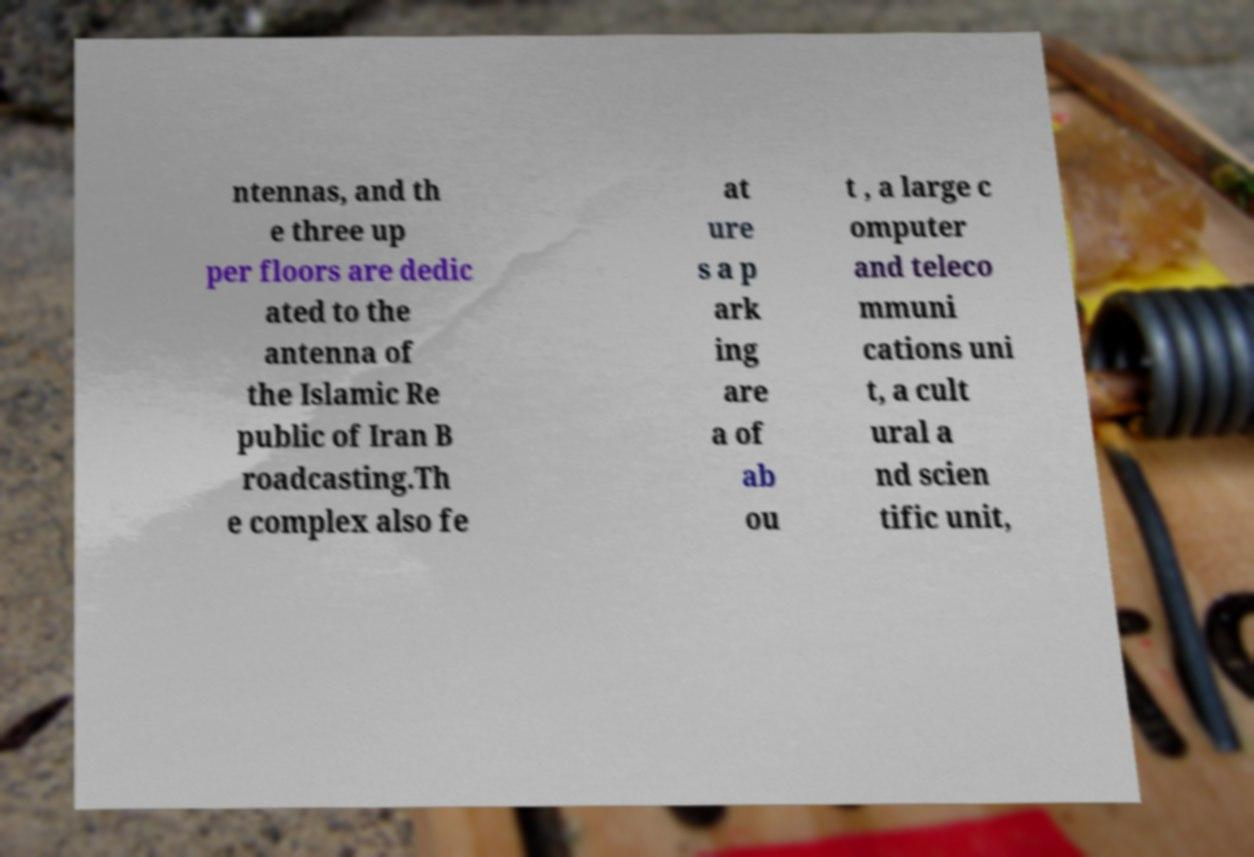Please identify and transcribe the text found in this image. ntennas, and th e three up per floors are dedic ated to the antenna of the Islamic Re public of Iran B roadcasting.Th e complex also fe at ure s a p ark ing are a of ab ou t , a large c omputer and teleco mmuni cations uni t, a cult ural a nd scien tific unit, 